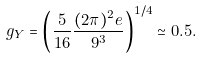Convert formula to latex. <formula><loc_0><loc_0><loc_500><loc_500>g _ { Y } = \left ( { \frac { 5 } { 1 6 } } { \frac { ( 2 \pi ) ^ { 2 } e } { 9 ^ { 3 } } } \right ) ^ { 1 / 4 } \simeq 0 . 5 .</formula> 